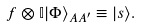<formula> <loc_0><loc_0><loc_500><loc_500>f \otimes \mathbb { I } | \Phi \rangle _ { A { A ^ { \prime } } } \equiv | s \rangle .</formula> 